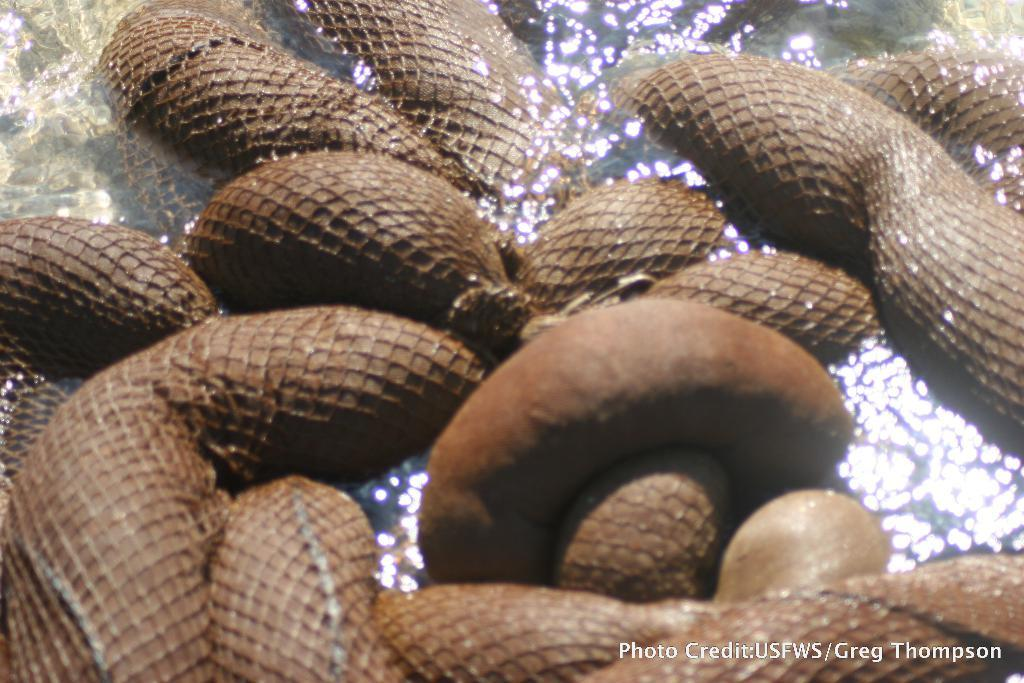What is the main subject of the image? There is an object in the center of the image. Where is the object located? The object is in the water. How many people are in the crowd surrounding the object in the image? There is no crowd present in the image; it only features an object in the water. What type of poison is being used to contaminate the water in the image? There is no indication of poison or contamination in the image; it simply shows an object in the water. 